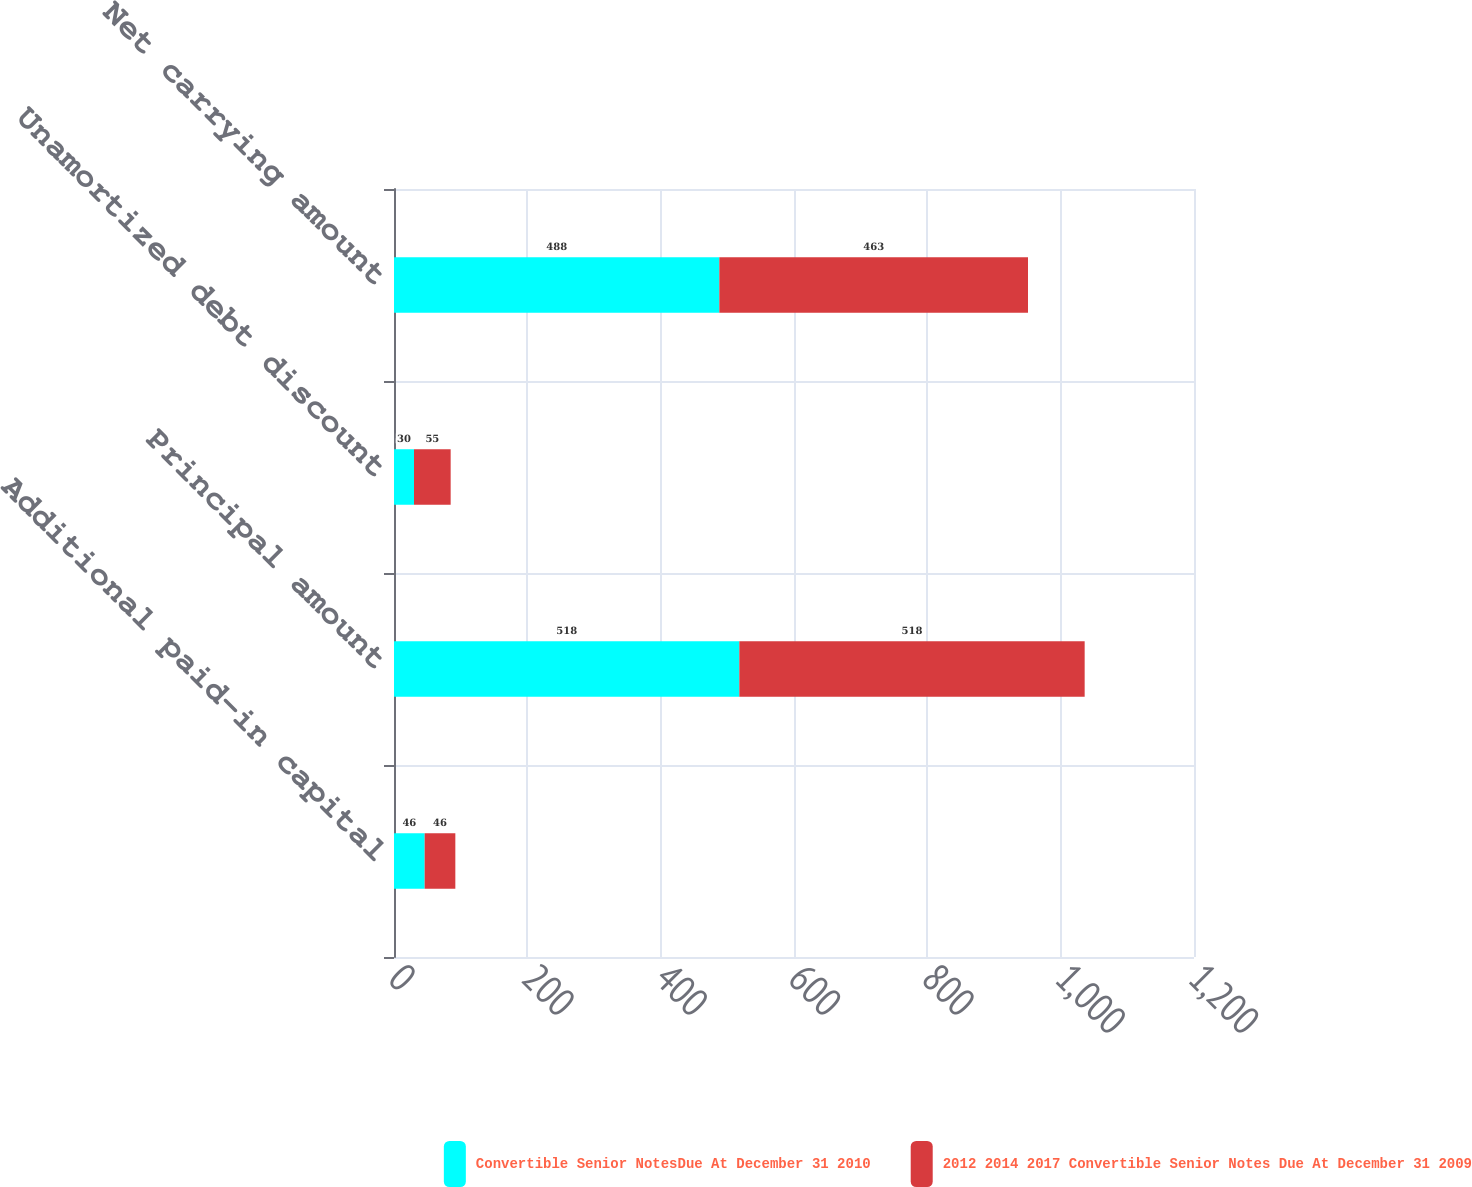<chart> <loc_0><loc_0><loc_500><loc_500><stacked_bar_chart><ecel><fcel>Additional paid-in capital<fcel>Principal amount<fcel>Unamortized debt discount<fcel>Net carrying amount<nl><fcel>Convertible Senior NotesDue At December 31 2010<fcel>46<fcel>518<fcel>30<fcel>488<nl><fcel>2012 2014 2017 Convertible Senior Notes Due At December 31 2009<fcel>46<fcel>518<fcel>55<fcel>463<nl></chart> 